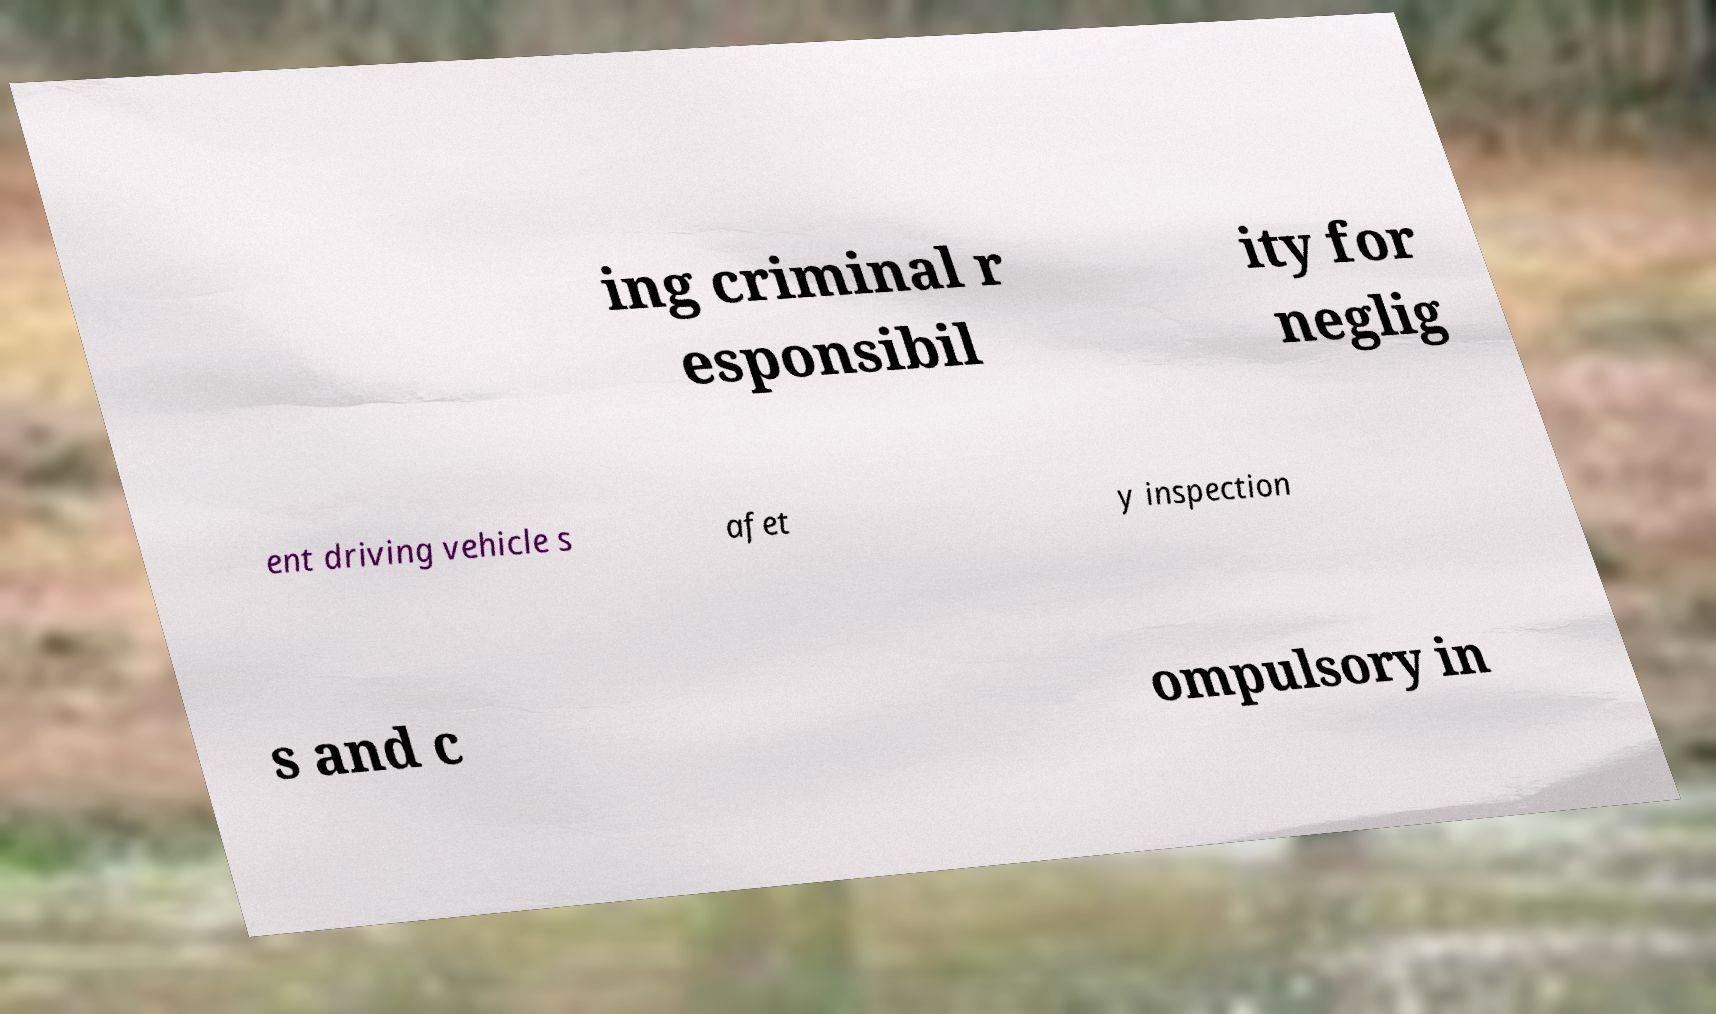For documentation purposes, I need the text within this image transcribed. Could you provide that? ing criminal r esponsibil ity for neglig ent driving vehicle s afet y inspection s and c ompulsory in 